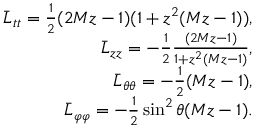<formula> <loc_0><loc_0><loc_500><loc_500>\begin{array} { r l r } & { \bar { L } _ { t t } = \frac { 1 } { 2 } ( 2 M z - 1 ) ( 1 + z ^ { 2 } ( M z - 1 ) ) , } \\ & { \bar { L } _ { z z } = - \frac { 1 } { 2 } \frac { ( 2 M z - 1 ) } { 1 + z ^ { 2 } ( M z - 1 ) } , } \\ & { \bar { L } _ { \theta \theta } = - \frac { 1 } { 2 } ( M z - 1 ) , } \\ & { \bar { L } _ { \varphi \varphi } = - \frac { 1 } { 2 } \sin ^ { 2 } \theta ( M z - 1 ) . } \end{array}</formula> 